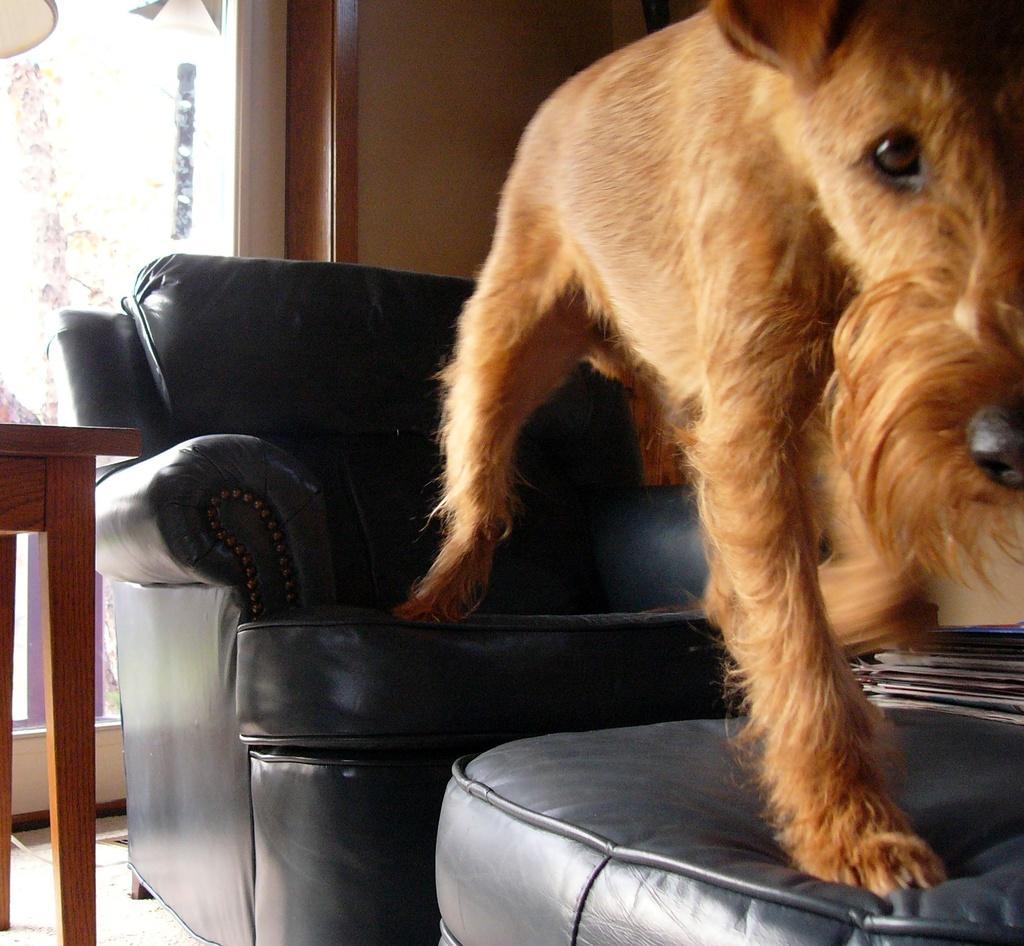Can you describe this image briefly? In the given image we can see a sofa and behind sofa there is a table, and there is a animal. 